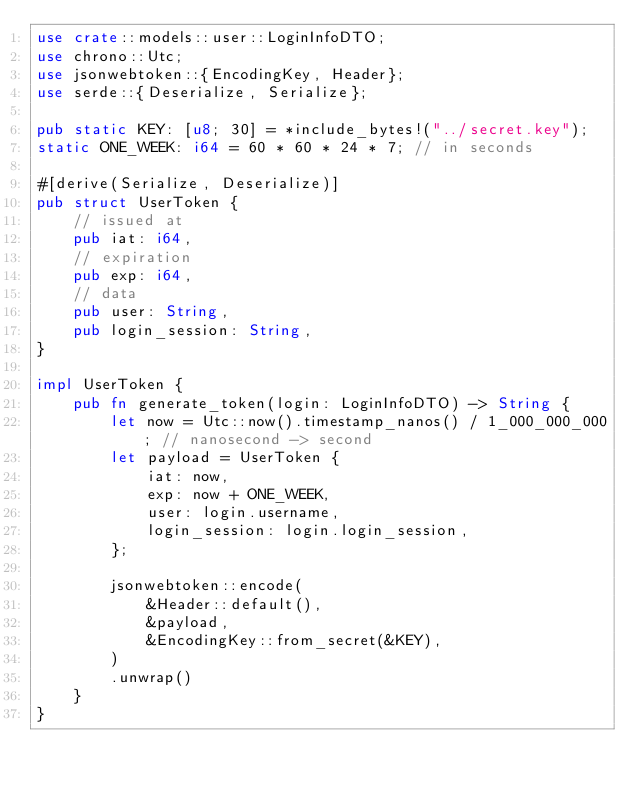Convert code to text. <code><loc_0><loc_0><loc_500><loc_500><_Rust_>use crate::models::user::LoginInfoDTO;
use chrono::Utc;
use jsonwebtoken::{EncodingKey, Header};
use serde::{Deserialize, Serialize};

pub static KEY: [u8; 30] = *include_bytes!("../secret.key");
static ONE_WEEK: i64 = 60 * 60 * 24 * 7; // in seconds

#[derive(Serialize, Deserialize)]
pub struct UserToken {
    // issued at
    pub iat: i64,
    // expiration
    pub exp: i64,
    // data
    pub user: String,
    pub login_session: String,
}

impl UserToken {
    pub fn generate_token(login: LoginInfoDTO) -> String {
        let now = Utc::now().timestamp_nanos() / 1_000_000_000; // nanosecond -> second
        let payload = UserToken {
            iat: now,
            exp: now + ONE_WEEK,
            user: login.username,
            login_session: login.login_session,
        };

        jsonwebtoken::encode(
            &Header::default(),
            &payload,
            &EncodingKey::from_secret(&KEY),
        )
        .unwrap()
    }
}
</code> 